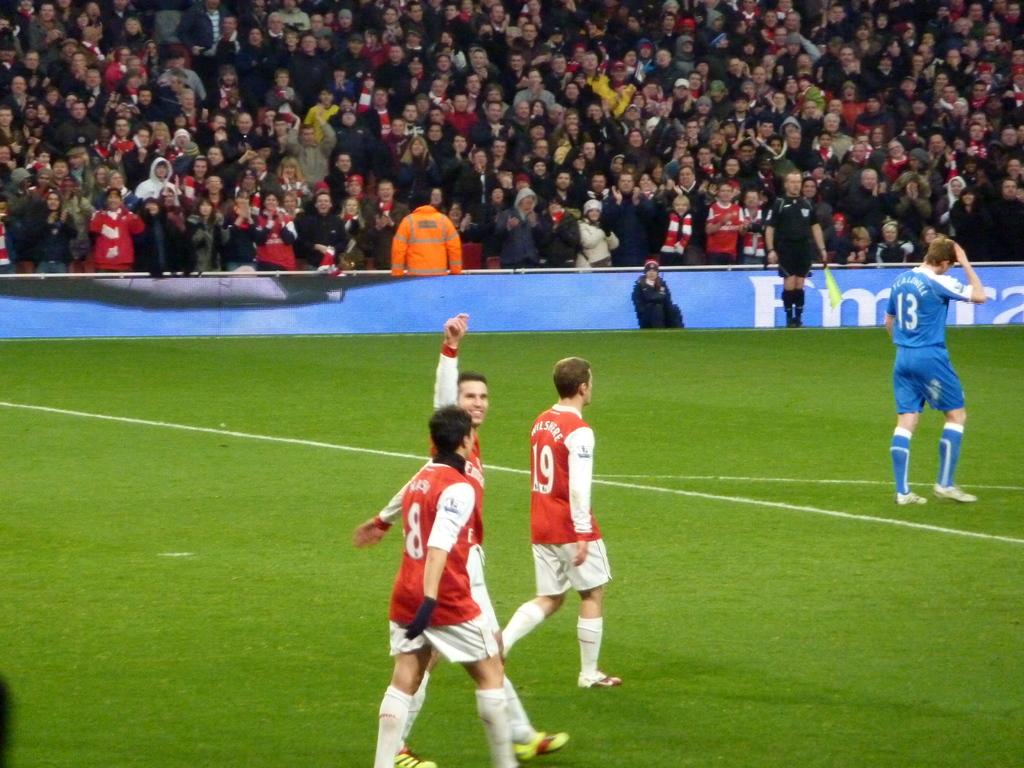<image>
Create a compact narrative representing the image presented. Men in red and blue on a sports field, the number 19 can been seen on one shirt. 